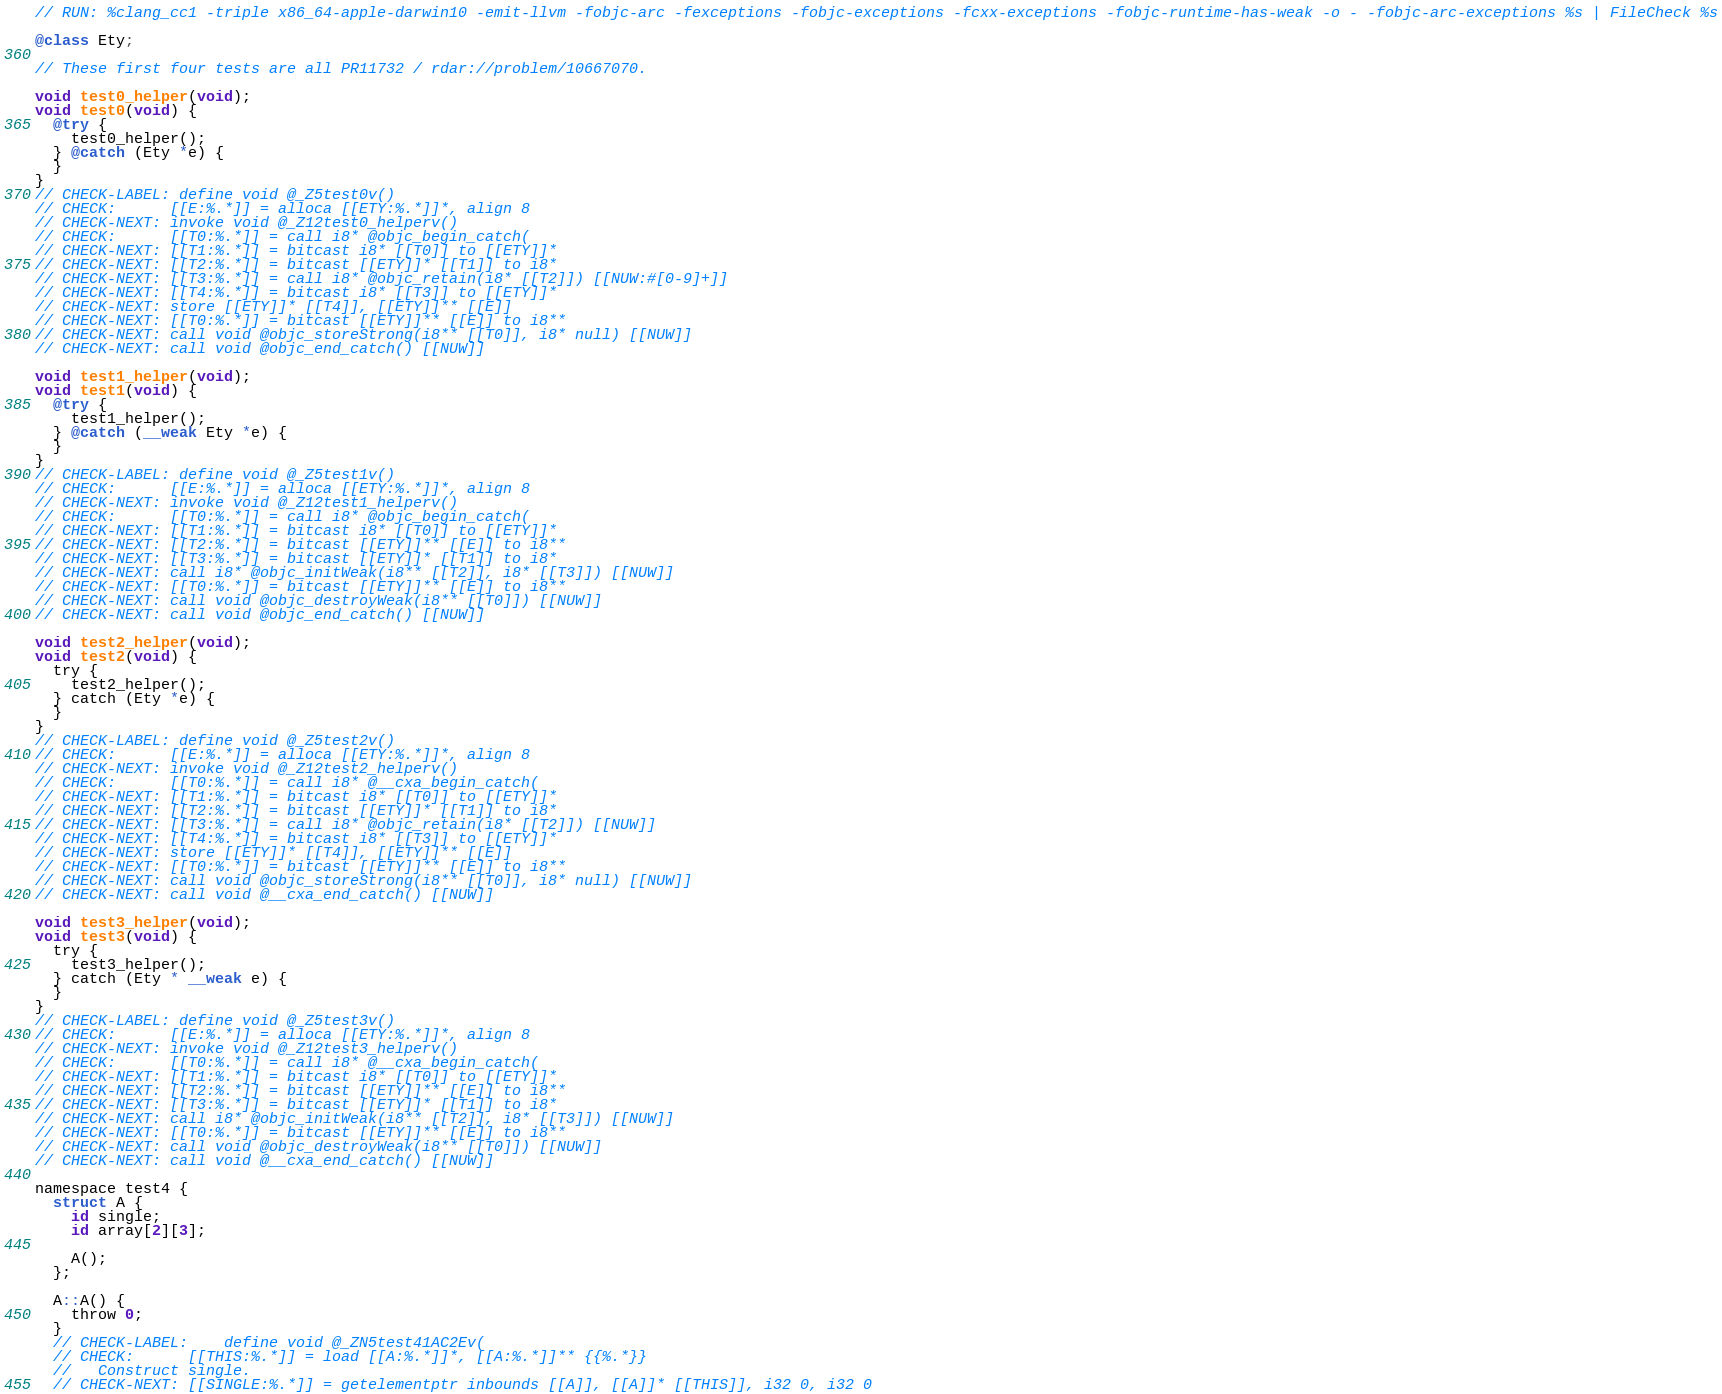Convert code to text. <code><loc_0><loc_0><loc_500><loc_500><_ObjectiveC_>// RUN: %clang_cc1 -triple x86_64-apple-darwin10 -emit-llvm -fobjc-arc -fexceptions -fobjc-exceptions -fcxx-exceptions -fobjc-runtime-has-weak -o - -fobjc-arc-exceptions %s | FileCheck %s

@class Ety;

// These first four tests are all PR11732 / rdar://problem/10667070.

void test0_helper(void);
void test0(void) {
  @try {
    test0_helper();
  } @catch (Ety *e) {
  }
}
// CHECK-LABEL: define void @_Z5test0v()
// CHECK:      [[E:%.*]] = alloca [[ETY:%.*]]*, align 8
// CHECK-NEXT: invoke void @_Z12test0_helperv()
// CHECK:      [[T0:%.*]] = call i8* @objc_begin_catch(
// CHECK-NEXT: [[T1:%.*]] = bitcast i8* [[T0]] to [[ETY]]*
// CHECK-NEXT: [[T2:%.*]] = bitcast [[ETY]]* [[T1]] to i8*
// CHECK-NEXT: [[T3:%.*]] = call i8* @objc_retain(i8* [[T2]]) [[NUW:#[0-9]+]]
// CHECK-NEXT: [[T4:%.*]] = bitcast i8* [[T3]] to [[ETY]]*
// CHECK-NEXT: store [[ETY]]* [[T4]], [[ETY]]** [[E]]
// CHECK-NEXT: [[T0:%.*]] = bitcast [[ETY]]** [[E]] to i8**
// CHECK-NEXT: call void @objc_storeStrong(i8** [[T0]], i8* null) [[NUW]]
// CHECK-NEXT: call void @objc_end_catch() [[NUW]]

void test1_helper(void);
void test1(void) {
  @try {
    test1_helper();
  } @catch (__weak Ety *e) {
  }
}
// CHECK-LABEL: define void @_Z5test1v()
// CHECK:      [[E:%.*]] = alloca [[ETY:%.*]]*, align 8
// CHECK-NEXT: invoke void @_Z12test1_helperv()
// CHECK:      [[T0:%.*]] = call i8* @objc_begin_catch(
// CHECK-NEXT: [[T1:%.*]] = bitcast i8* [[T0]] to [[ETY]]*
// CHECK-NEXT: [[T2:%.*]] = bitcast [[ETY]]** [[E]] to i8**
// CHECK-NEXT: [[T3:%.*]] = bitcast [[ETY]]* [[T1]] to i8*
// CHECK-NEXT: call i8* @objc_initWeak(i8** [[T2]], i8* [[T3]]) [[NUW]]
// CHECK-NEXT: [[T0:%.*]] = bitcast [[ETY]]** [[E]] to i8**
// CHECK-NEXT: call void @objc_destroyWeak(i8** [[T0]]) [[NUW]]
// CHECK-NEXT: call void @objc_end_catch() [[NUW]]

void test2_helper(void);
void test2(void) {
  try {
    test2_helper();
  } catch (Ety *e) {
  }
}
// CHECK-LABEL: define void @_Z5test2v()
// CHECK:      [[E:%.*]] = alloca [[ETY:%.*]]*, align 8
// CHECK-NEXT: invoke void @_Z12test2_helperv()
// CHECK:      [[T0:%.*]] = call i8* @__cxa_begin_catch(
// CHECK-NEXT: [[T1:%.*]] = bitcast i8* [[T0]] to [[ETY]]*
// CHECK-NEXT: [[T2:%.*]] = bitcast [[ETY]]* [[T1]] to i8*
// CHECK-NEXT: [[T3:%.*]] = call i8* @objc_retain(i8* [[T2]]) [[NUW]]
// CHECK-NEXT: [[T4:%.*]] = bitcast i8* [[T3]] to [[ETY]]*
// CHECK-NEXT: store [[ETY]]* [[T4]], [[ETY]]** [[E]]
// CHECK-NEXT: [[T0:%.*]] = bitcast [[ETY]]** [[E]] to i8**
// CHECK-NEXT: call void @objc_storeStrong(i8** [[T0]], i8* null) [[NUW]]
// CHECK-NEXT: call void @__cxa_end_catch() [[NUW]]

void test3_helper(void);
void test3(void) {
  try {
    test3_helper();
  } catch (Ety * __weak e) {
  }
}
// CHECK-LABEL: define void @_Z5test3v()
// CHECK:      [[E:%.*]] = alloca [[ETY:%.*]]*, align 8
// CHECK-NEXT: invoke void @_Z12test3_helperv()
// CHECK:      [[T0:%.*]] = call i8* @__cxa_begin_catch(
// CHECK-NEXT: [[T1:%.*]] = bitcast i8* [[T0]] to [[ETY]]*
// CHECK-NEXT: [[T2:%.*]] = bitcast [[ETY]]** [[E]] to i8**
// CHECK-NEXT: [[T3:%.*]] = bitcast [[ETY]]* [[T1]] to i8*
// CHECK-NEXT: call i8* @objc_initWeak(i8** [[T2]], i8* [[T3]]) [[NUW]]
// CHECK-NEXT: [[T0:%.*]] = bitcast [[ETY]]** [[E]] to i8**
// CHECK-NEXT: call void @objc_destroyWeak(i8** [[T0]]) [[NUW]]
// CHECK-NEXT: call void @__cxa_end_catch() [[NUW]]

namespace test4 {
  struct A {
    id single;
    id array[2][3];

    A();
  };

  A::A() {
    throw 0;
  }
  // CHECK-LABEL:    define void @_ZN5test41AC2Ev(
  // CHECK:      [[THIS:%.*]] = load [[A:%.*]]*, [[A:%.*]]** {{%.*}}
  //   Construct single.
  // CHECK-NEXT: [[SINGLE:%.*]] = getelementptr inbounds [[A]], [[A]]* [[THIS]], i32 0, i32 0</code> 